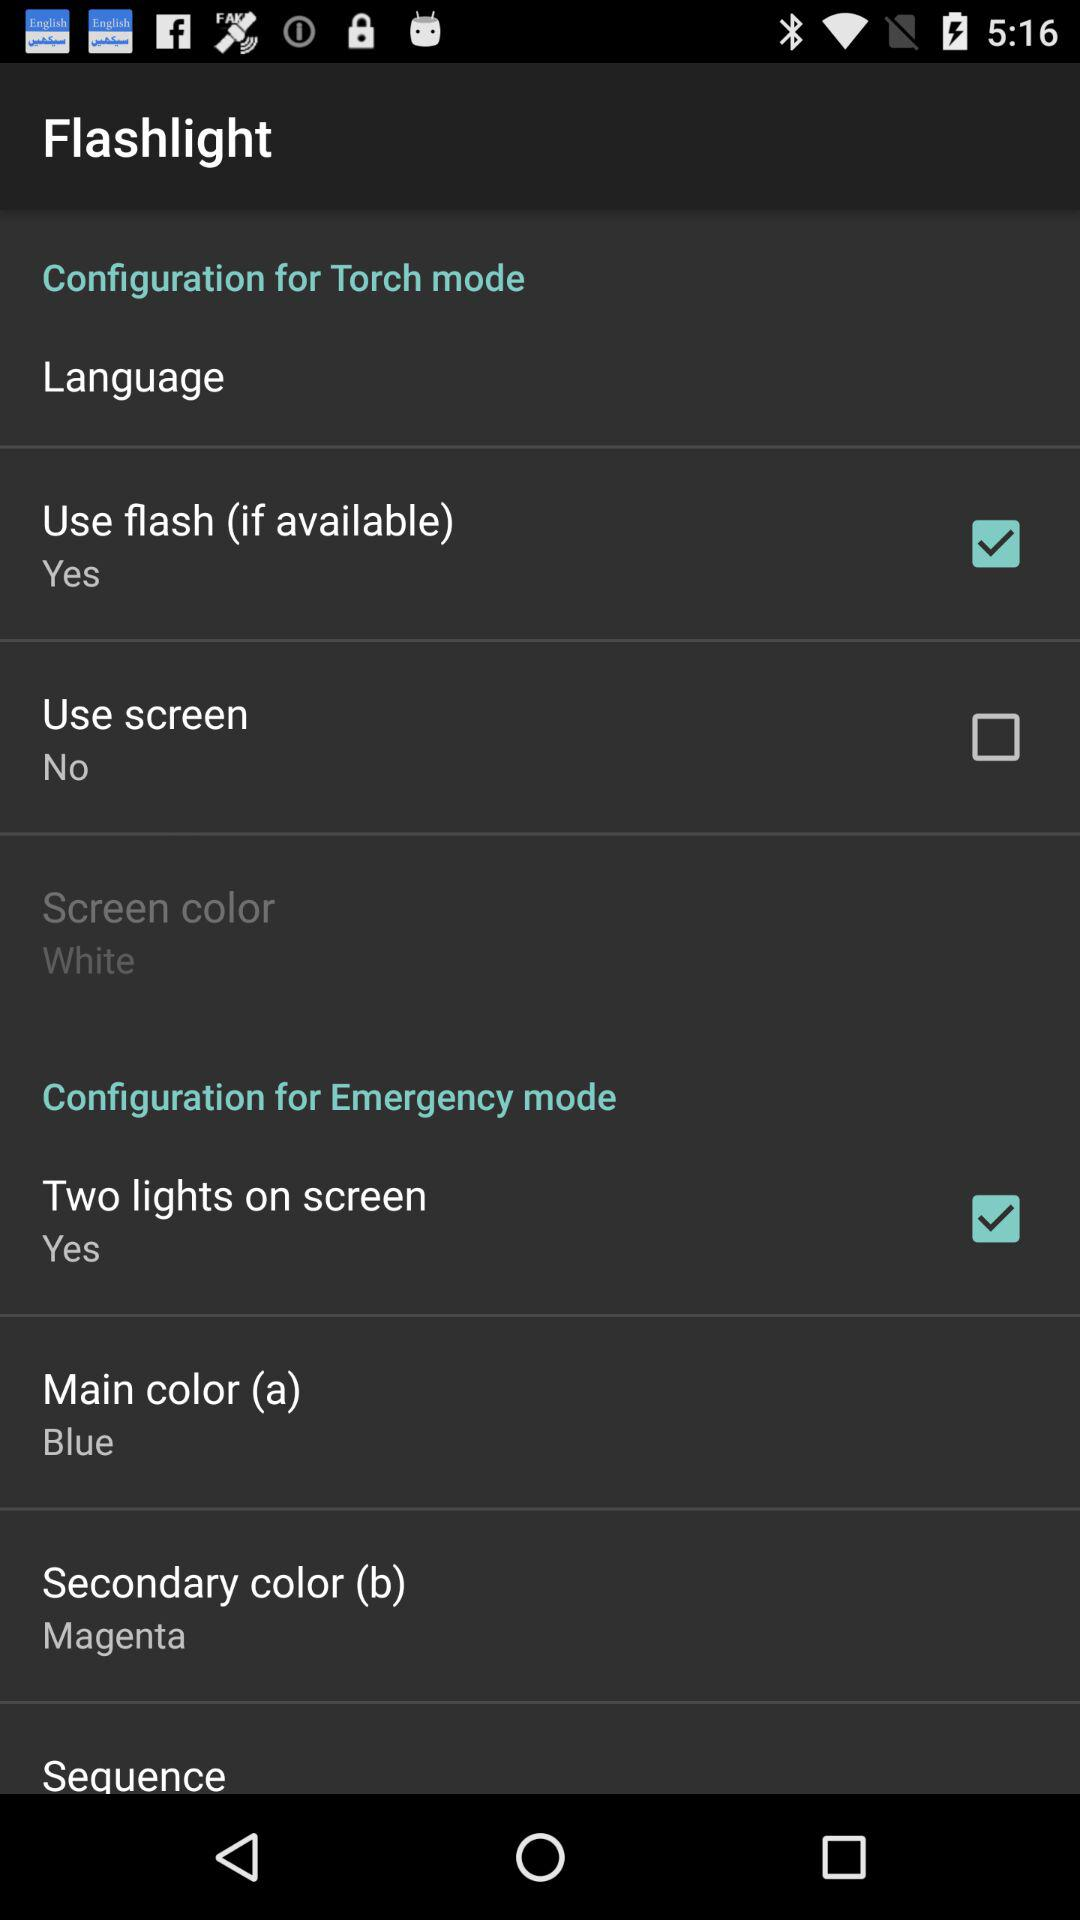Which colors are available to be selected as a main color?
When the provided information is insufficient, respond with <no answer>. <no answer> 